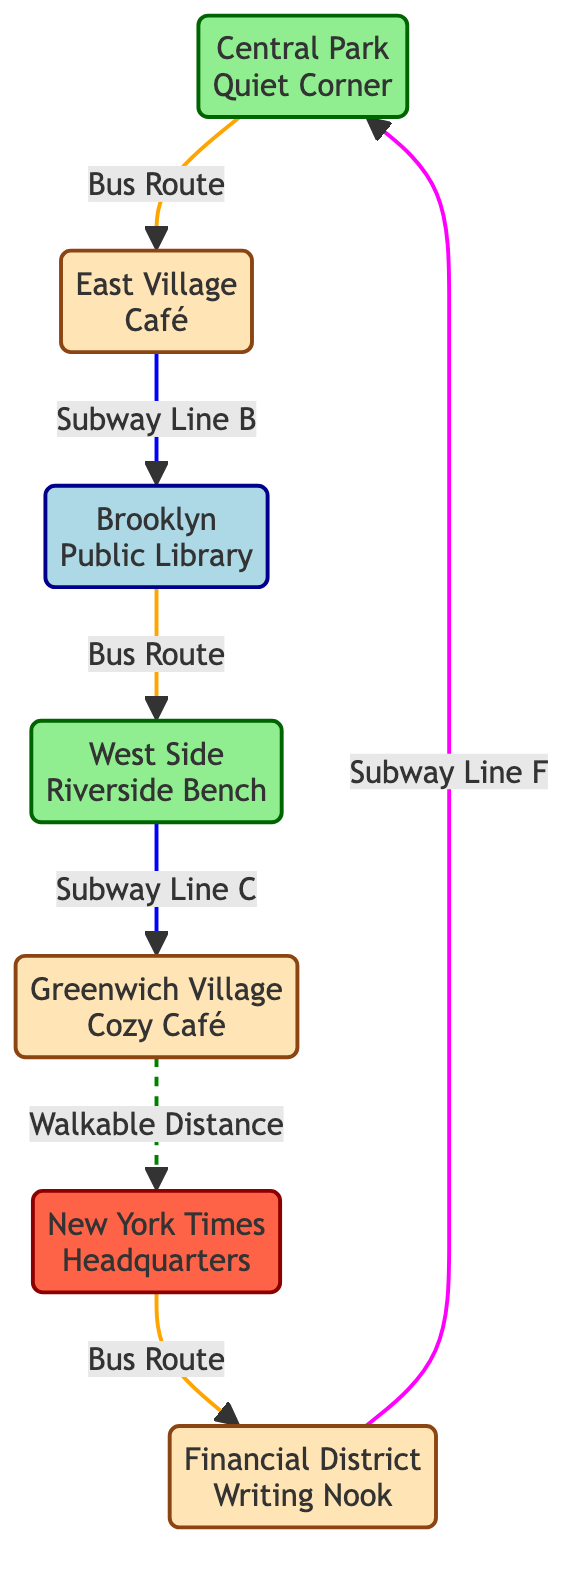What types of nodes are represented in the diagram? The diagram includes three types of nodes: Parks, Cafés, Libraries, and News Hotspots. Each node belongs to one of these categories, as indicated by their color coding in the diagram.
Answer: Parks, Cafés, Libraries, News Hotspots How many nodes are there in total? The diagram consists of seven nodes, which can be counted directly from the list provided in the data. Each unique location represents a separate node in the network.
Answer: 7 What is the connection type between the Central Park Quiet Corner and East Village Café? The edge connecting Central Park Quiet Corner to East Village Café is labeled as a Bus Route. This indicates how one can travel between these two locations within the network.
Answer: Bus Route Which node is connected to the Brooklyn Public Library by a Bus Route? The node connected to Brooklyn Public Library via a Bus Route is West Side Riverside Bench. This connection enables travel between these two specific locations.
Answer: West Side Riverside Bench How many different public transport routes are shown in the diagram? The diagram displays four different public transport route types: Bus Routes and Subway Lines. Each edge is labeled to specify the type of transport connecting the nodes.
Answer: 4 Where can one find a writing spot closest to the New York Times Headquarters? The writing spot closest to New York Times Headquarters is Greenwich Village Cozy Café, which is connected to it by a walkable distance, highlighting easy access.
Answer: Greenwich Village Cozy Café What is the route type between Financial District Writing Nook and Central Park Quiet Corner? The route type connecting Financial District Writing Nook to Central Park Quiet Corner is the Subway Line F. This demonstrates the public transport options available within the network.
Answer: Subway Line F What is the shortest path from East Village Café to Brooklyn Public Library? The shortest path from East Village Café to Brooklyn Public Library is through the Subway Line B. It directly connects these two locations with the least amount of travel transfer.
Answer: Subway Line B How many edges are connected to the Greenwich Village Cozy Café? Greenwich Village Cozy Café has two edges connected to it: one leading to New York Times Headquarters (walkable distance) and one leading to West Side Riverside Bench (subway line C), indicating multiple travel options.
Answer: 2 